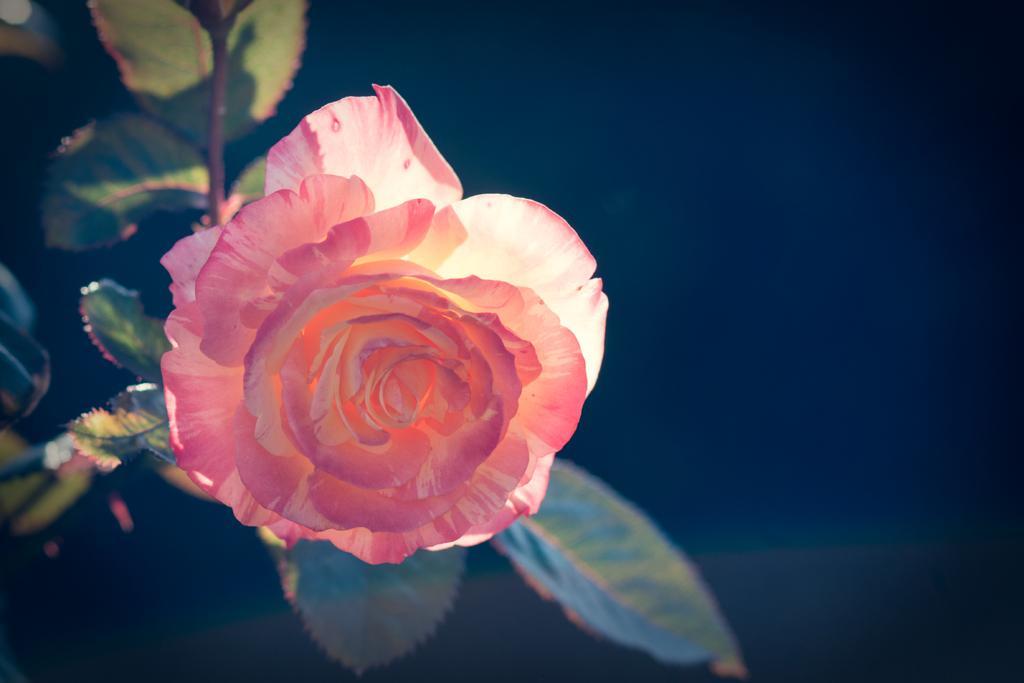Could you give a brief overview of what you see in this image? In the center of the image we can see flower to the plant. 